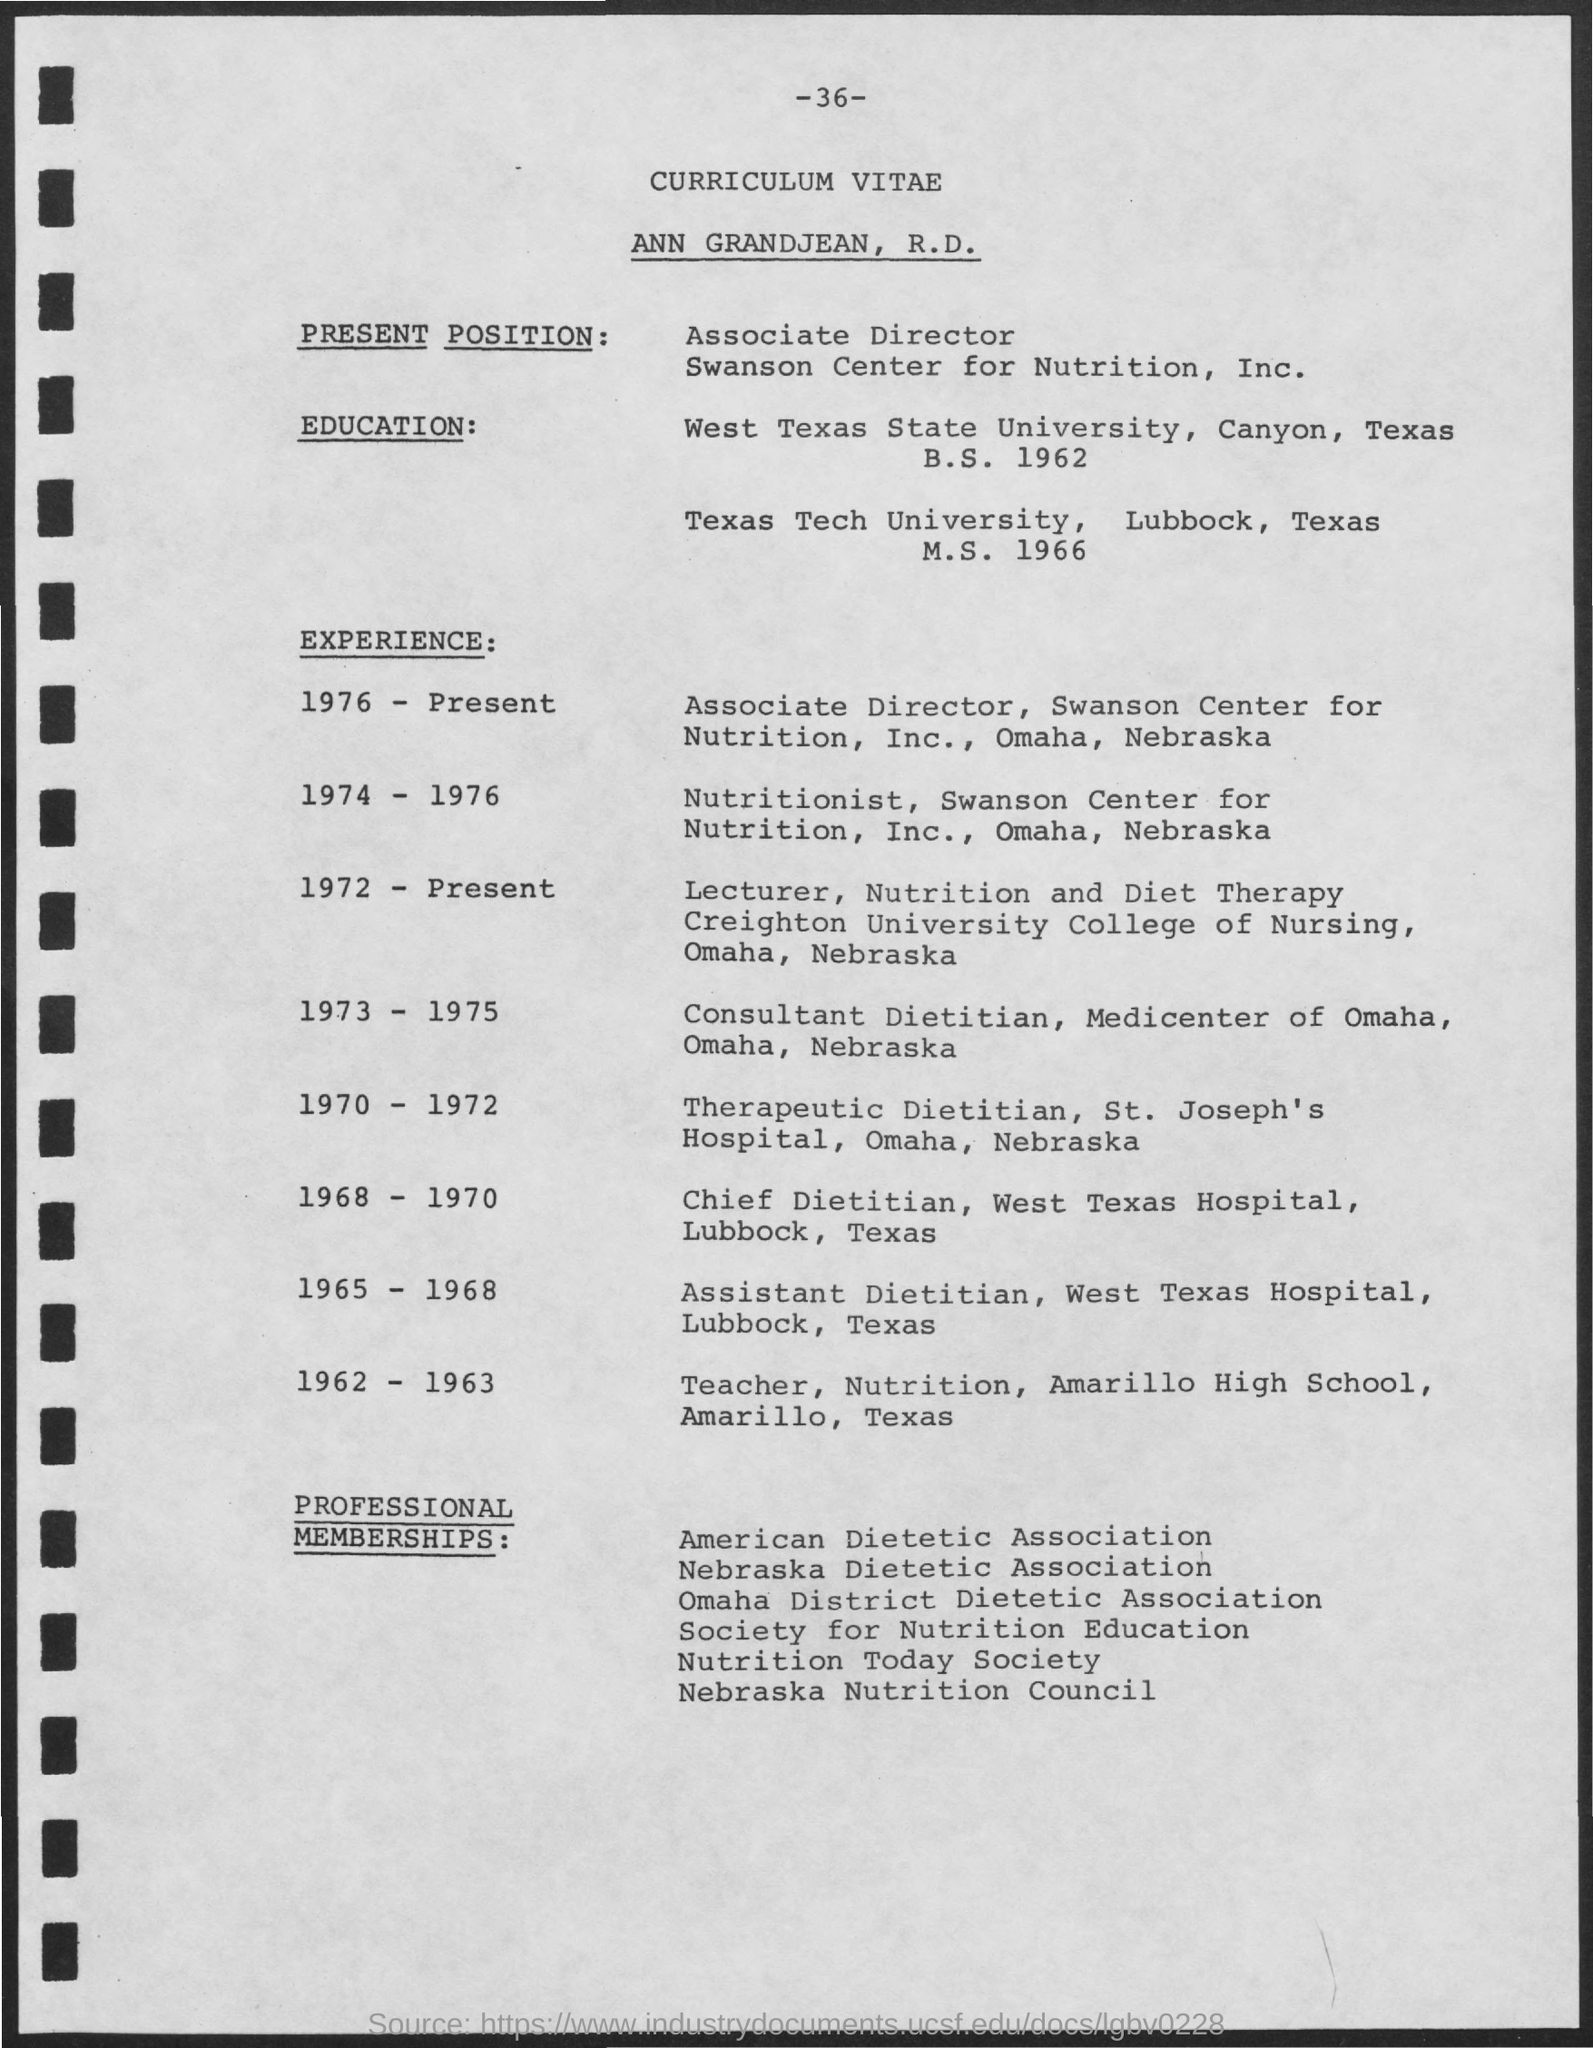List a handful of essential elements in this visual. Ann Grandjean is currently the Associate Director of the Swanson Center for Nutrition, Inc. Ann Grandjean, R.D. completed her B.S. degree in 1962. The page number mentioned in this document is 36. During the years 1965 to 1968, ANN GRANDJEAN, R.D., held the job title of Assistant Dietitian at West Texas Hospital. ANN GRANDJEAN, R.D., worked as a consultant Dietitian at the Medicenter of Omaha during the years 1973 to 1975. 